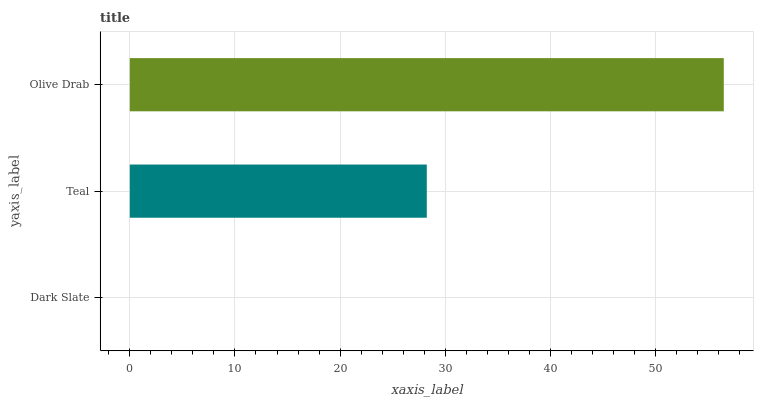Is Dark Slate the minimum?
Answer yes or no. Yes. Is Olive Drab the maximum?
Answer yes or no. Yes. Is Teal the minimum?
Answer yes or no. No. Is Teal the maximum?
Answer yes or no. No. Is Teal greater than Dark Slate?
Answer yes or no. Yes. Is Dark Slate less than Teal?
Answer yes or no. Yes. Is Dark Slate greater than Teal?
Answer yes or no. No. Is Teal less than Dark Slate?
Answer yes or no. No. Is Teal the high median?
Answer yes or no. Yes. Is Teal the low median?
Answer yes or no. Yes. Is Dark Slate the high median?
Answer yes or no. No. Is Olive Drab the low median?
Answer yes or no. No. 